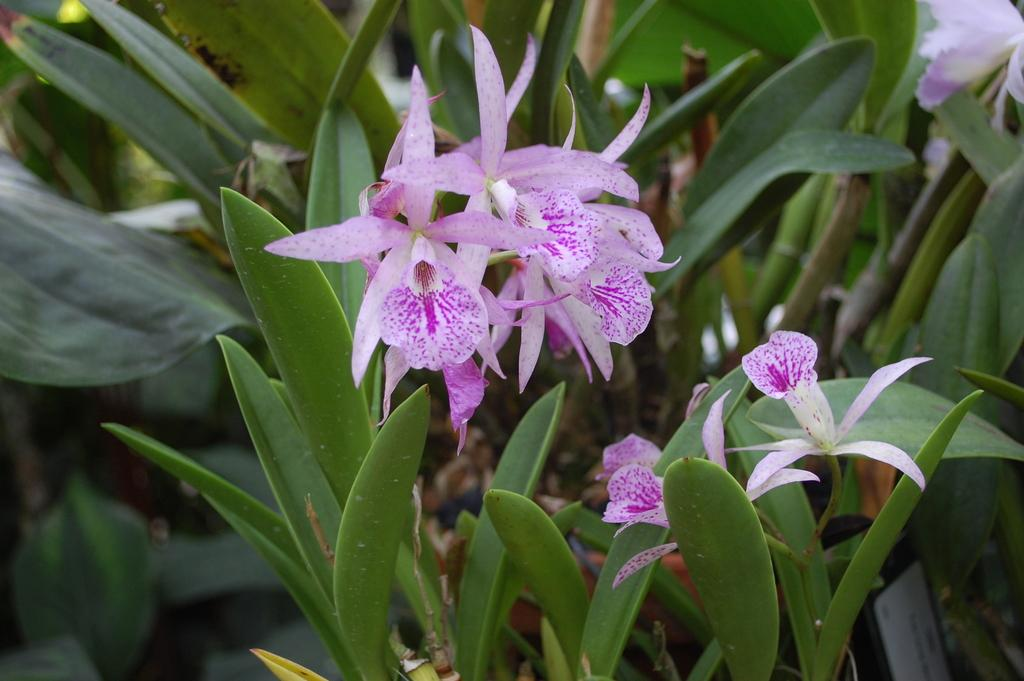What type of flora can be seen in the image? There are flowers in the image. What can be seen in the background of the image? There are green plants in the background of the image. Can you describe the object on the right side of the image? Unfortunately, the facts provided do not give enough information to describe the object on the right side of the image. How does the bait affect the fish in the image? There is no fish or bait present in the image, so it is not possible to determine how bait might affect fish in this context. 